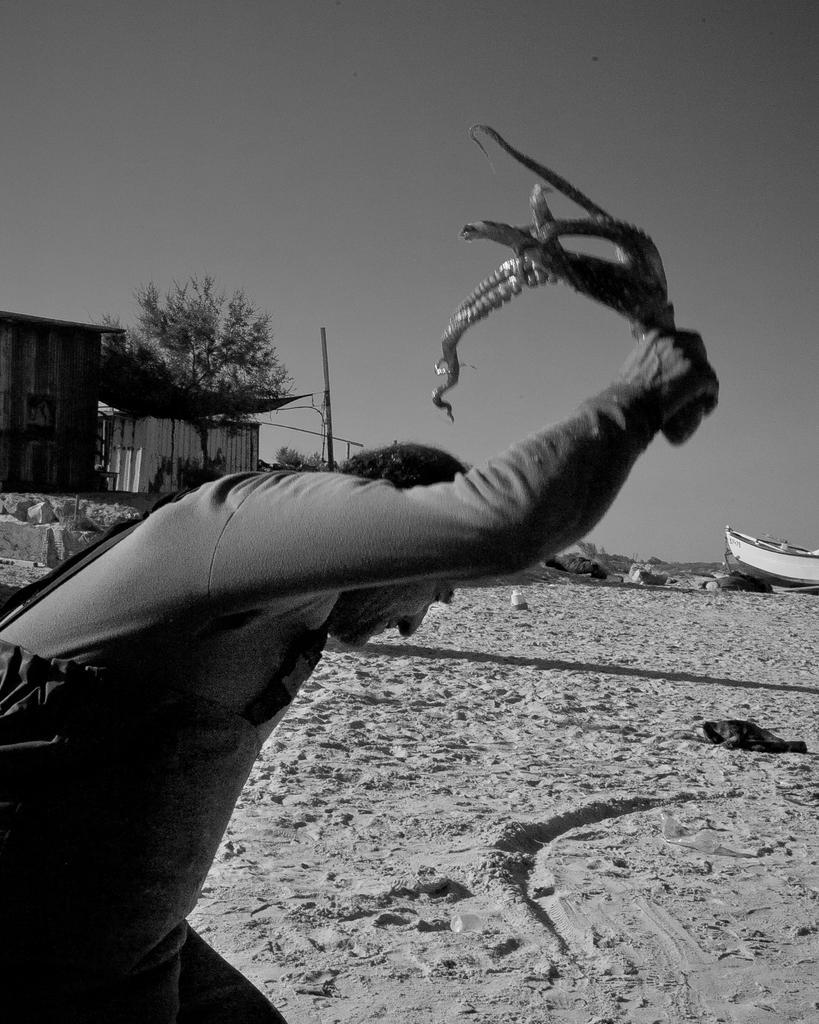In one or two sentences, can you explain what this image depicts? This is a black and white picture. I can see a person standing and holding an animal, there is a boat on the sand, there are sheds, there are trees, and in the background there is the sky. 